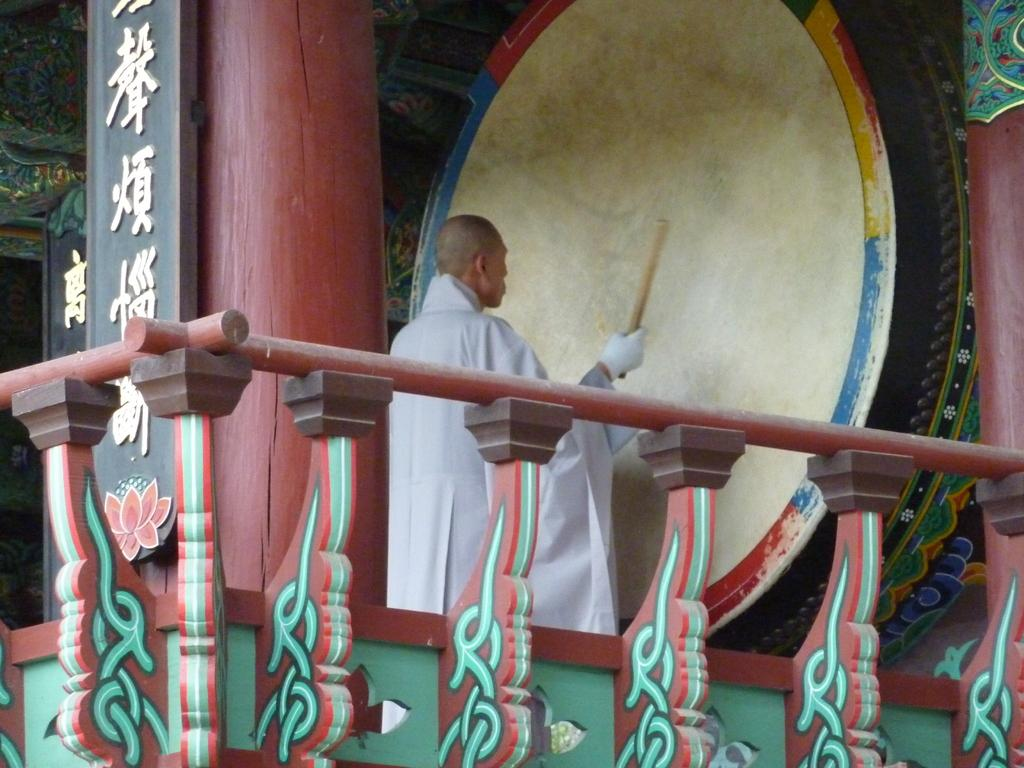What is the main subject of the image? There is a man in the middle of the image. What is the man holding in the image? The man is holding a stick. What can be seen on the left side of the image? There is some text on the left side of the image. What type of collar is the man wearing in the image? There is no collar visible on the man in the image. How many arrows can be seen in the quiver on the man's back in the image? There is no quiver or arrows present in the image. 